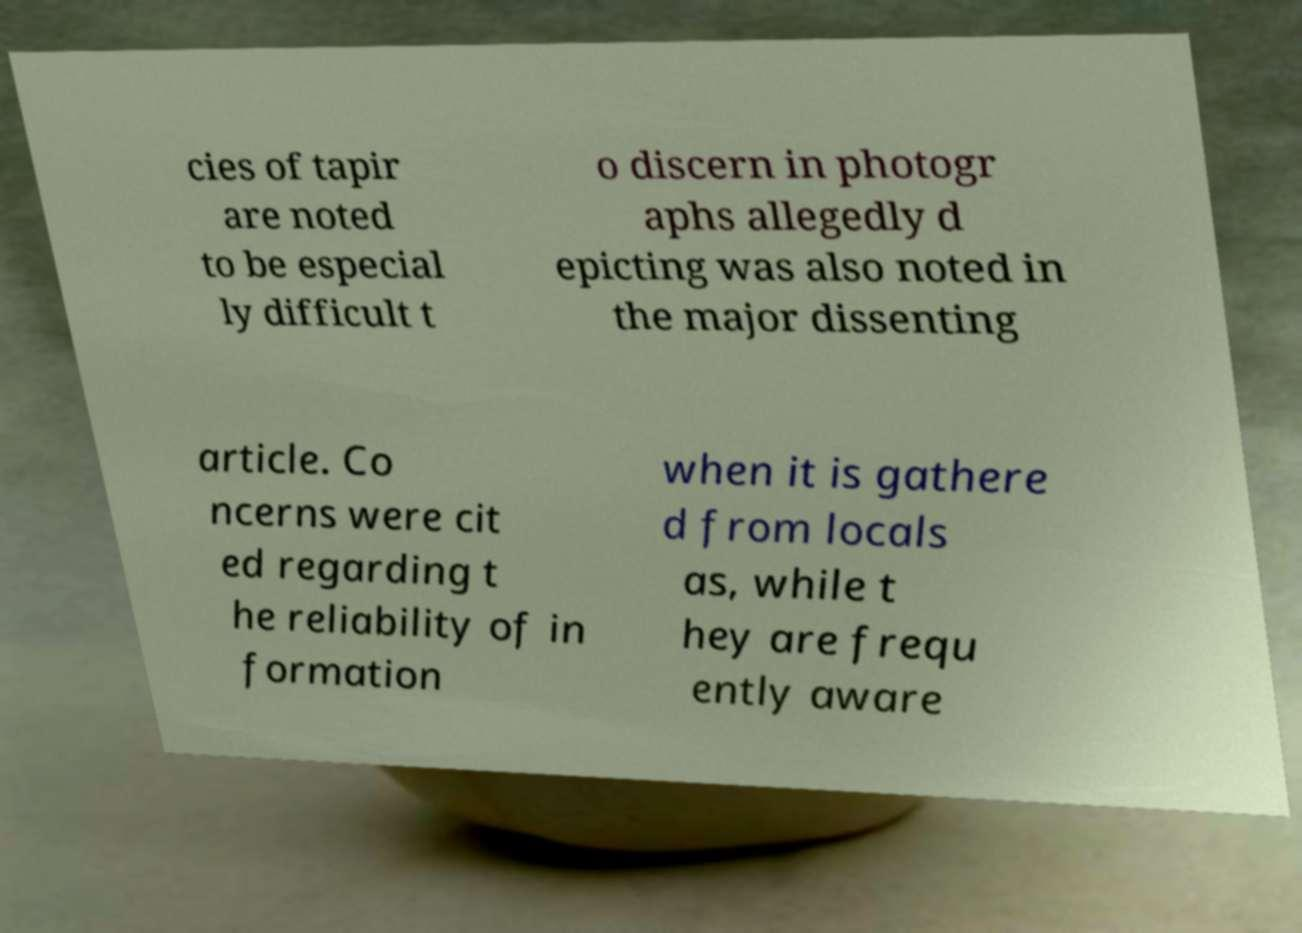For documentation purposes, I need the text within this image transcribed. Could you provide that? cies of tapir are noted to be especial ly difficult t o discern in photogr aphs allegedly d epicting was also noted in the major dissenting article. Co ncerns were cit ed regarding t he reliability of in formation when it is gathere d from locals as, while t hey are frequ ently aware 